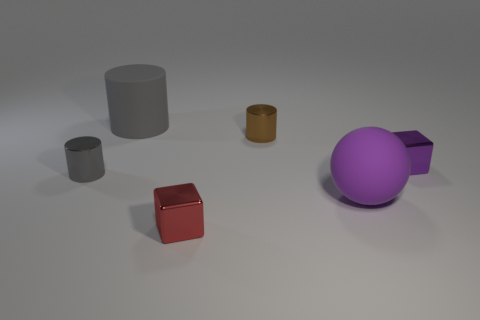Add 3 purple metal cylinders. How many objects exist? 9 Subtract all cubes. How many objects are left? 4 Add 3 small purple blocks. How many small purple blocks are left? 4 Add 3 tiny gray matte cylinders. How many tiny gray matte cylinders exist? 3 Subtract 1 purple cubes. How many objects are left? 5 Subtract all tiny cyan metallic objects. Subtract all large things. How many objects are left? 4 